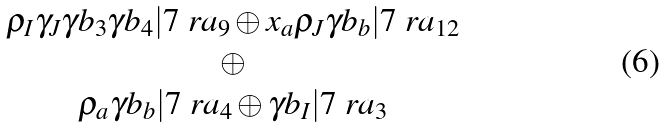<formula> <loc_0><loc_0><loc_500><loc_500>\begin{matrix} \rho _ { I } \gamma _ { J } \gamma b _ { 3 } \gamma b _ { 4 } | 7 \ r a _ { 9 } \oplus x _ { a } \rho _ { J } \gamma b _ { b } | 7 \ r a _ { 1 2 } \\ \oplus \\ \rho _ { a } \gamma b _ { b } | 7 \ r a _ { 4 } \oplus \gamma b _ { I } | 7 \ r a _ { 3 } \end{matrix}</formula> 